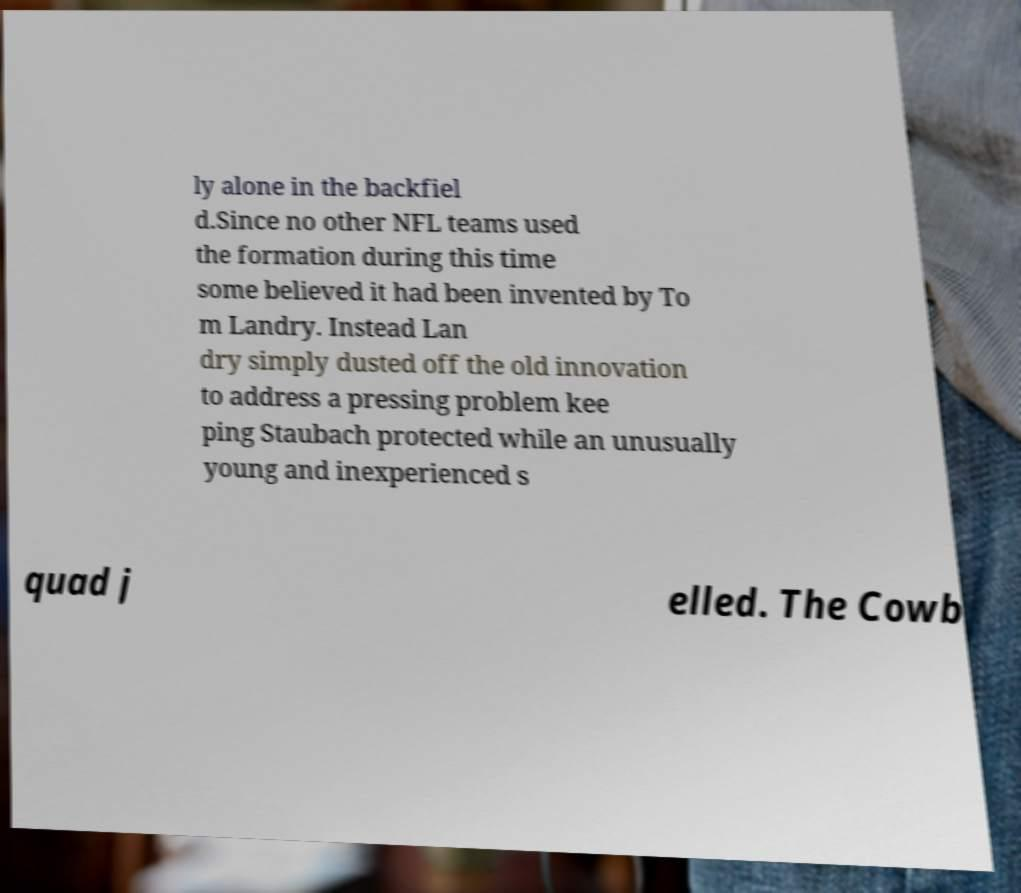Could you assist in decoding the text presented in this image and type it out clearly? ly alone in the backfiel d.Since no other NFL teams used the formation during this time some believed it had been invented by To m Landry. Instead Lan dry simply dusted off the old innovation to address a pressing problem kee ping Staubach protected while an unusually young and inexperienced s quad j elled. The Cowb 